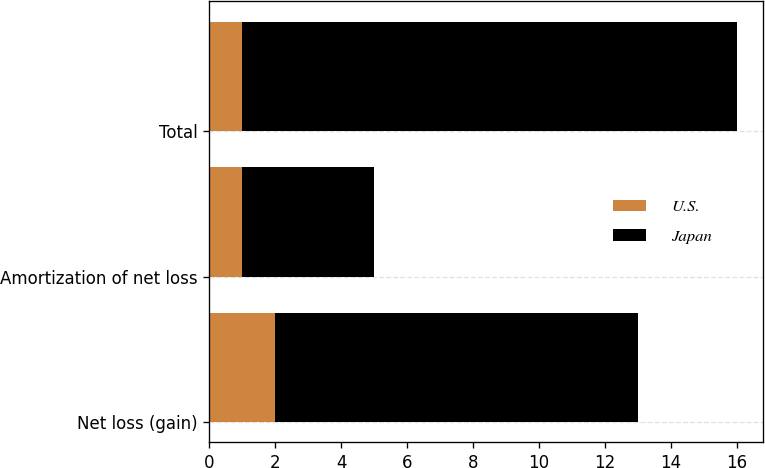Convert chart. <chart><loc_0><loc_0><loc_500><loc_500><stacked_bar_chart><ecel><fcel>Net loss (gain)<fcel>Amortization of net loss<fcel>Total<nl><fcel>U.S.<fcel>2<fcel>1<fcel>1<nl><fcel>Japan<fcel>11<fcel>4<fcel>15<nl></chart> 